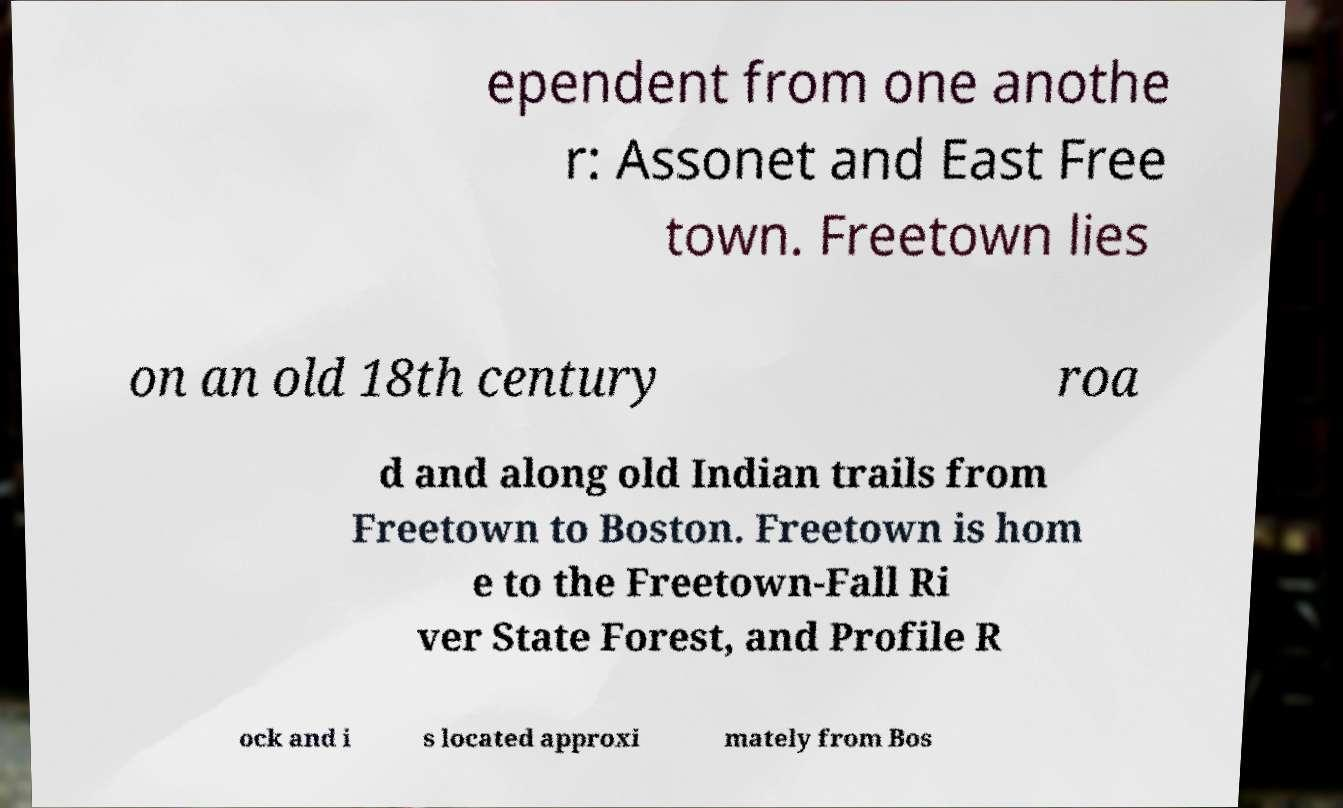There's text embedded in this image that I need extracted. Can you transcribe it verbatim? ependent from one anothe r: Assonet and East Free town. Freetown lies on an old 18th century roa d and along old Indian trails from Freetown to Boston. Freetown is hom e to the Freetown-Fall Ri ver State Forest, and Profile R ock and i s located approxi mately from Bos 